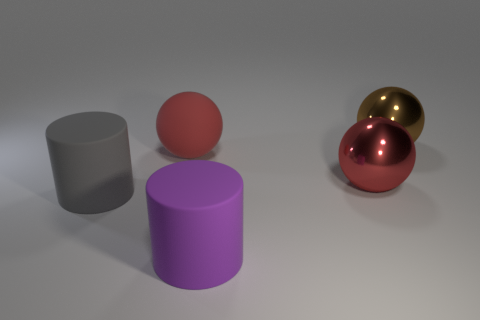What number of other objects are there of the same size as the matte ball?
Offer a terse response. 4. There is a ball that is in front of the big red thing that is behind the big red shiny thing; what is its material?
Offer a very short reply. Metal. Do the brown object and the red sphere to the right of the purple cylinder have the same size?
Your response must be concise. Yes. Are there any rubber things of the same color as the rubber ball?
Give a very brief answer. No. What number of tiny objects are brown things or gray cylinders?
Ensure brevity in your answer.  0. What number of large green shiny spheres are there?
Offer a very short reply. 0. What is the material of the brown object behind the large gray rubber cylinder?
Your answer should be very brief. Metal. Are there any large red metallic things in front of the big purple cylinder?
Keep it short and to the point. No. Is the size of the matte sphere the same as the purple rubber object?
Your answer should be compact. Yes. How many red balls are made of the same material as the gray object?
Your answer should be compact. 1. 